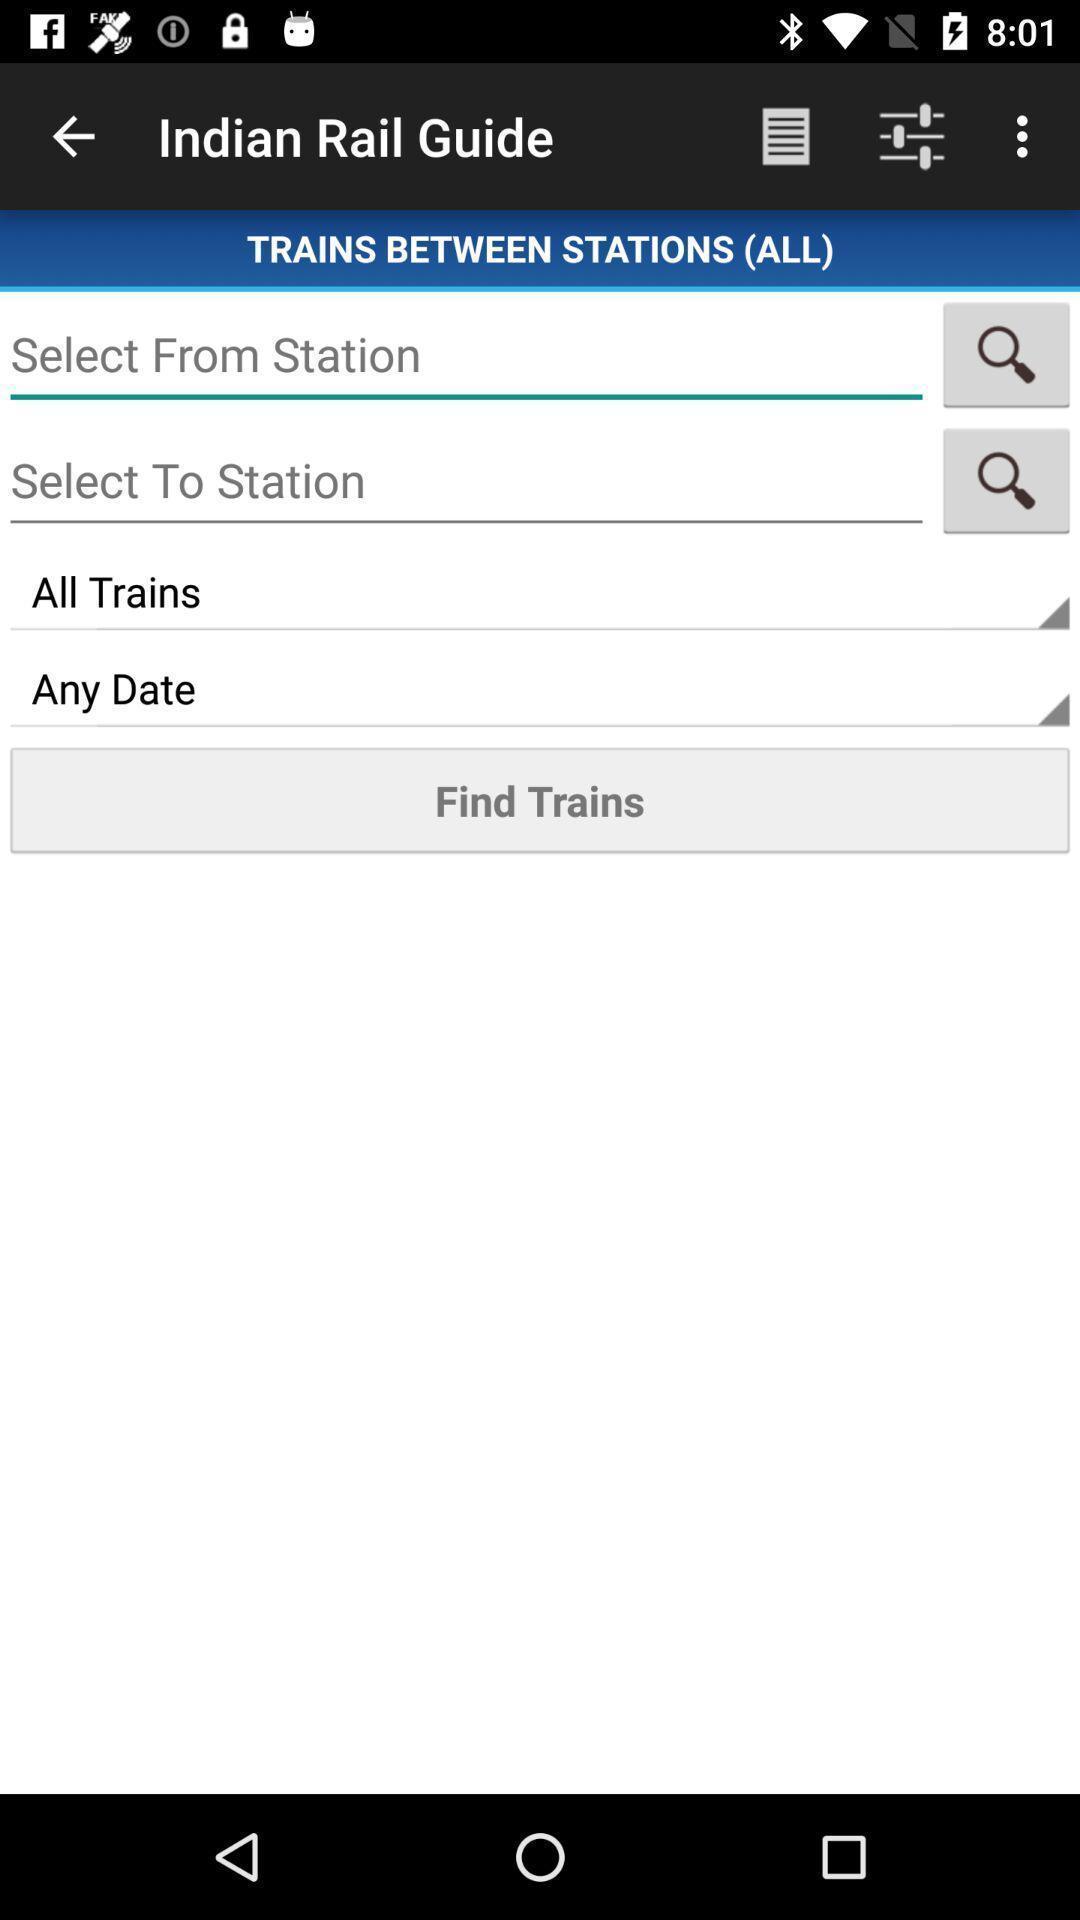Describe the visual elements of this screenshot. Screen showing search bar to find trains in travel app. 